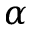Convert formula to latex. <formula><loc_0><loc_0><loc_500><loc_500>\alpha</formula> 